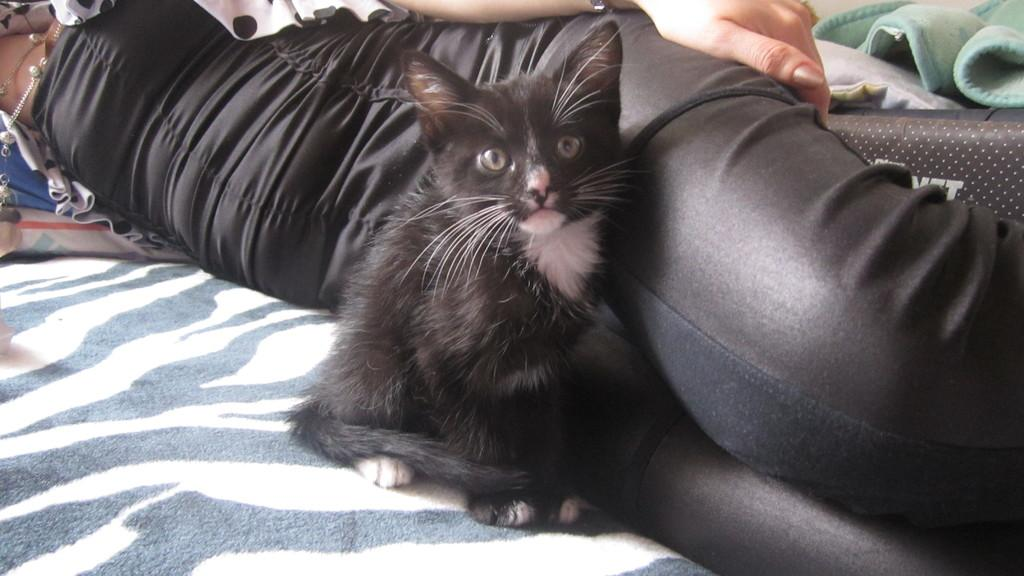What type of animal is in the image? There is a cat in the image. What is the person in the image doing? The person is lying down in the image. What is the person wearing? The person is wearing clothes. How many children are playing with the crow in the image? There is no crow or children present in the image. What type of wound does the person have on their arm in the image? There is no wound visible on the person in the image. 